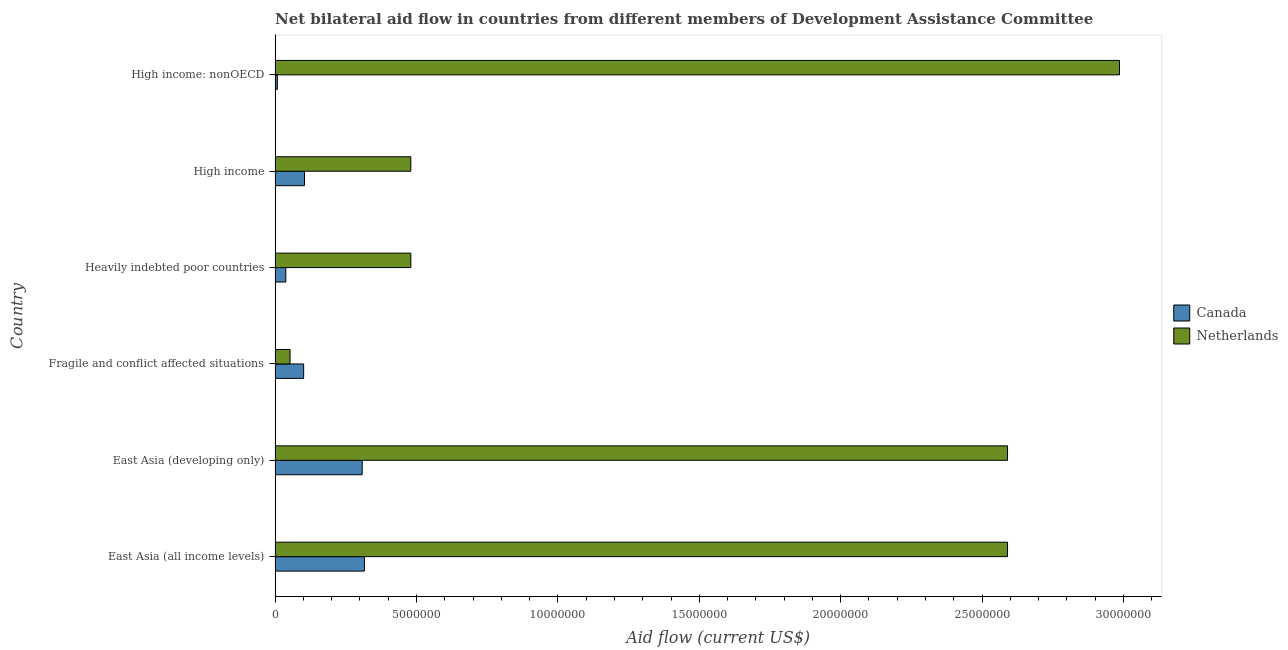How many bars are there on the 4th tick from the bottom?
Your answer should be very brief. 2. What is the label of the 1st group of bars from the top?
Provide a short and direct response. High income: nonOECD. In how many cases, is the number of bars for a given country not equal to the number of legend labels?
Your answer should be compact. 0. What is the amount of aid given by netherlands in East Asia (all income levels)?
Offer a very short reply. 2.59e+07. Across all countries, what is the maximum amount of aid given by canada?
Offer a very short reply. 3.16e+06. Across all countries, what is the minimum amount of aid given by netherlands?
Provide a short and direct response. 5.30e+05. In which country was the amount of aid given by netherlands maximum?
Give a very brief answer. High income: nonOECD. In which country was the amount of aid given by netherlands minimum?
Provide a short and direct response. Fragile and conflict affected situations. What is the total amount of aid given by canada in the graph?
Your response must be concise. 8.75e+06. What is the difference between the amount of aid given by netherlands in East Asia (all income levels) and that in Heavily indebted poor countries?
Your answer should be compact. 2.11e+07. What is the difference between the amount of aid given by canada in East Asia (all income levels) and the amount of aid given by netherlands in High income: nonOECD?
Your response must be concise. -2.67e+07. What is the average amount of aid given by canada per country?
Offer a very short reply. 1.46e+06. What is the difference between the amount of aid given by netherlands and amount of aid given by canada in East Asia (all income levels)?
Provide a short and direct response. 2.27e+07. In how many countries, is the amount of aid given by netherlands greater than 21000000 US$?
Provide a short and direct response. 3. What is the ratio of the amount of aid given by canada in Fragile and conflict affected situations to that in Heavily indebted poor countries?
Ensure brevity in your answer.  2.66. Is the amount of aid given by canada in East Asia (developing only) less than that in Fragile and conflict affected situations?
Make the answer very short. No. What is the difference between the highest and the second highest amount of aid given by netherlands?
Keep it short and to the point. 3.96e+06. What is the difference between the highest and the lowest amount of aid given by netherlands?
Give a very brief answer. 2.93e+07. In how many countries, is the amount of aid given by netherlands greater than the average amount of aid given by netherlands taken over all countries?
Your answer should be compact. 3. What does the 1st bar from the top in High income represents?
Make the answer very short. Netherlands. How many bars are there?
Provide a succinct answer. 12. Are all the bars in the graph horizontal?
Ensure brevity in your answer.  Yes. What is the difference between two consecutive major ticks on the X-axis?
Provide a short and direct response. 5.00e+06. Does the graph contain any zero values?
Ensure brevity in your answer.  No. Does the graph contain grids?
Give a very brief answer. No. What is the title of the graph?
Offer a very short reply. Net bilateral aid flow in countries from different members of Development Assistance Committee. What is the label or title of the X-axis?
Your answer should be compact. Aid flow (current US$). What is the label or title of the Y-axis?
Offer a very short reply. Country. What is the Aid flow (current US$) of Canada in East Asia (all income levels)?
Your answer should be compact. 3.16e+06. What is the Aid flow (current US$) in Netherlands in East Asia (all income levels)?
Give a very brief answer. 2.59e+07. What is the Aid flow (current US$) of Canada in East Asia (developing only)?
Keep it short and to the point. 3.08e+06. What is the Aid flow (current US$) in Netherlands in East Asia (developing only)?
Provide a succinct answer. 2.59e+07. What is the Aid flow (current US$) of Canada in Fragile and conflict affected situations?
Offer a very short reply. 1.01e+06. What is the Aid flow (current US$) in Netherlands in Fragile and conflict affected situations?
Give a very brief answer. 5.30e+05. What is the Aid flow (current US$) of Canada in Heavily indebted poor countries?
Your response must be concise. 3.80e+05. What is the Aid flow (current US$) in Netherlands in Heavily indebted poor countries?
Your answer should be very brief. 4.80e+06. What is the Aid flow (current US$) in Canada in High income?
Offer a terse response. 1.04e+06. What is the Aid flow (current US$) in Netherlands in High income?
Offer a terse response. 4.80e+06. What is the Aid flow (current US$) of Netherlands in High income: nonOECD?
Ensure brevity in your answer.  2.99e+07. Across all countries, what is the maximum Aid flow (current US$) in Canada?
Provide a short and direct response. 3.16e+06. Across all countries, what is the maximum Aid flow (current US$) in Netherlands?
Your response must be concise. 2.99e+07. Across all countries, what is the minimum Aid flow (current US$) in Netherlands?
Provide a succinct answer. 5.30e+05. What is the total Aid flow (current US$) of Canada in the graph?
Offer a very short reply. 8.75e+06. What is the total Aid flow (current US$) in Netherlands in the graph?
Keep it short and to the point. 9.18e+07. What is the difference between the Aid flow (current US$) of Canada in East Asia (all income levels) and that in East Asia (developing only)?
Your answer should be very brief. 8.00e+04. What is the difference between the Aid flow (current US$) in Netherlands in East Asia (all income levels) and that in East Asia (developing only)?
Make the answer very short. 0. What is the difference between the Aid flow (current US$) of Canada in East Asia (all income levels) and that in Fragile and conflict affected situations?
Give a very brief answer. 2.15e+06. What is the difference between the Aid flow (current US$) of Netherlands in East Asia (all income levels) and that in Fragile and conflict affected situations?
Provide a short and direct response. 2.54e+07. What is the difference between the Aid flow (current US$) in Canada in East Asia (all income levels) and that in Heavily indebted poor countries?
Provide a succinct answer. 2.78e+06. What is the difference between the Aid flow (current US$) in Netherlands in East Asia (all income levels) and that in Heavily indebted poor countries?
Offer a terse response. 2.11e+07. What is the difference between the Aid flow (current US$) of Canada in East Asia (all income levels) and that in High income?
Offer a very short reply. 2.12e+06. What is the difference between the Aid flow (current US$) of Netherlands in East Asia (all income levels) and that in High income?
Your answer should be very brief. 2.11e+07. What is the difference between the Aid flow (current US$) in Canada in East Asia (all income levels) and that in High income: nonOECD?
Your answer should be compact. 3.08e+06. What is the difference between the Aid flow (current US$) of Netherlands in East Asia (all income levels) and that in High income: nonOECD?
Provide a short and direct response. -3.96e+06. What is the difference between the Aid flow (current US$) in Canada in East Asia (developing only) and that in Fragile and conflict affected situations?
Offer a terse response. 2.07e+06. What is the difference between the Aid flow (current US$) in Netherlands in East Asia (developing only) and that in Fragile and conflict affected situations?
Your answer should be compact. 2.54e+07. What is the difference between the Aid flow (current US$) in Canada in East Asia (developing only) and that in Heavily indebted poor countries?
Give a very brief answer. 2.70e+06. What is the difference between the Aid flow (current US$) of Netherlands in East Asia (developing only) and that in Heavily indebted poor countries?
Offer a terse response. 2.11e+07. What is the difference between the Aid flow (current US$) of Canada in East Asia (developing only) and that in High income?
Ensure brevity in your answer.  2.04e+06. What is the difference between the Aid flow (current US$) of Netherlands in East Asia (developing only) and that in High income?
Offer a terse response. 2.11e+07. What is the difference between the Aid flow (current US$) of Canada in East Asia (developing only) and that in High income: nonOECD?
Your answer should be very brief. 3.00e+06. What is the difference between the Aid flow (current US$) in Netherlands in East Asia (developing only) and that in High income: nonOECD?
Your answer should be very brief. -3.96e+06. What is the difference between the Aid flow (current US$) of Canada in Fragile and conflict affected situations and that in Heavily indebted poor countries?
Ensure brevity in your answer.  6.30e+05. What is the difference between the Aid flow (current US$) in Netherlands in Fragile and conflict affected situations and that in Heavily indebted poor countries?
Ensure brevity in your answer.  -4.27e+06. What is the difference between the Aid flow (current US$) of Canada in Fragile and conflict affected situations and that in High income?
Make the answer very short. -3.00e+04. What is the difference between the Aid flow (current US$) of Netherlands in Fragile and conflict affected situations and that in High income?
Your response must be concise. -4.27e+06. What is the difference between the Aid flow (current US$) of Canada in Fragile and conflict affected situations and that in High income: nonOECD?
Your answer should be compact. 9.30e+05. What is the difference between the Aid flow (current US$) in Netherlands in Fragile and conflict affected situations and that in High income: nonOECD?
Give a very brief answer. -2.93e+07. What is the difference between the Aid flow (current US$) of Canada in Heavily indebted poor countries and that in High income?
Provide a succinct answer. -6.60e+05. What is the difference between the Aid flow (current US$) of Netherlands in Heavily indebted poor countries and that in High income?
Provide a succinct answer. 0. What is the difference between the Aid flow (current US$) in Canada in Heavily indebted poor countries and that in High income: nonOECD?
Offer a terse response. 3.00e+05. What is the difference between the Aid flow (current US$) in Netherlands in Heavily indebted poor countries and that in High income: nonOECD?
Your response must be concise. -2.51e+07. What is the difference between the Aid flow (current US$) of Canada in High income and that in High income: nonOECD?
Your answer should be compact. 9.60e+05. What is the difference between the Aid flow (current US$) in Netherlands in High income and that in High income: nonOECD?
Give a very brief answer. -2.51e+07. What is the difference between the Aid flow (current US$) of Canada in East Asia (all income levels) and the Aid flow (current US$) of Netherlands in East Asia (developing only)?
Provide a succinct answer. -2.27e+07. What is the difference between the Aid flow (current US$) in Canada in East Asia (all income levels) and the Aid flow (current US$) in Netherlands in Fragile and conflict affected situations?
Provide a succinct answer. 2.63e+06. What is the difference between the Aid flow (current US$) in Canada in East Asia (all income levels) and the Aid flow (current US$) in Netherlands in Heavily indebted poor countries?
Ensure brevity in your answer.  -1.64e+06. What is the difference between the Aid flow (current US$) of Canada in East Asia (all income levels) and the Aid flow (current US$) of Netherlands in High income?
Provide a short and direct response. -1.64e+06. What is the difference between the Aid flow (current US$) in Canada in East Asia (all income levels) and the Aid flow (current US$) in Netherlands in High income: nonOECD?
Provide a short and direct response. -2.67e+07. What is the difference between the Aid flow (current US$) of Canada in East Asia (developing only) and the Aid flow (current US$) of Netherlands in Fragile and conflict affected situations?
Your answer should be compact. 2.55e+06. What is the difference between the Aid flow (current US$) of Canada in East Asia (developing only) and the Aid flow (current US$) of Netherlands in Heavily indebted poor countries?
Your answer should be compact. -1.72e+06. What is the difference between the Aid flow (current US$) in Canada in East Asia (developing only) and the Aid flow (current US$) in Netherlands in High income?
Make the answer very short. -1.72e+06. What is the difference between the Aid flow (current US$) of Canada in East Asia (developing only) and the Aid flow (current US$) of Netherlands in High income: nonOECD?
Ensure brevity in your answer.  -2.68e+07. What is the difference between the Aid flow (current US$) in Canada in Fragile and conflict affected situations and the Aid flow (current US$) in Netherlands in Heavily indebted poor countries?
Offer a terse response. -3.79e+06. What is the difference between the Aid flow (current US$) of Canada in Fragile and conflict affected situations and the Aid flow (current US$) of Netherlands in High income?
Offer a very short reply. -3.79e+06. What is the difference between the Aid flow (current US$) in Canada in Fragile and conflict affected situations and the Aid flow (current US$) in Netherlands in High income: nonOECD?
Your answer should be compact. -2.88e+07. What is the difference between the Aid flow (current US$) of Canada in Heavily indebted poor countries and the Aid flow (current US$) of Netherlands in High income?
Your response must be concise. -4.42e+06. What is the difference between the Aid flow (current US$) of Canada in Heavily indebted poor countries and the Aid flow (current US$) of Netherlands in High income: nonOECD?
Offer a terse response. -2.95e+07. What is the difference between the Aid flow (current US$) in Canada in High income and the Aid flow (current US$) in Netherlands in High income: nonOECD?
Give a very brief answer. -2.88e+07. What is the average Aid flow (current US$) of Canada per country?
Offer a terse response. 1.46e+06. What is the average Aid flow (current US$) in Netherlands per country?
Your answer should be compact. 1.53e+07. What is the difference between the Aid flow (current US$) of Canada and Aid flow (current US$) of Netherlands in East Asia (all income levels)?
Ensure brevity in your answer.  -2.27e+07. What is the difference between the Aid flow (current US$) of Canada and Aid flow (current US$) of Netherlands in East Asia (developing only)?
Give a very brief answer. -2.28e+07. What is the difference between the Aid flow (current US$) of Canada and Aid flow (current US$) of Netherlands in Heavily indebted poor countries?
Your answer should be compact. -4.42e+06. What is the difference between the Aid flow (current US$) in Canada and Aid flow (current US$) in Netherlands in High income?
Your answer should be compact. -3.76e+06. What is the difference between the Aid flow (current US$) of Canada and Aid flow (current US$) of Netherlands in High income: nonOECD?
Your answer should be compact. -2.98e+07. What is the ratio of the Aid flow (current US$) in Canada in East Asia (all income levels) to that in East Asia (developing only)?
Provide a short and direct response. 1.03. What is the ratio of the Aid flow (current US$) in Netherlands in East Asia (all income levels) to that in East Asia (developing only)?
Give a very brief answer. 1. What is the ratio of the Aid flow (current US$) in Canada in East Asia (all income levels) to that in Fragile and conflict affected situations?
Your answer should be very brief. 3.13. What is the ratio of the Aid flow (current US$) of Netherlands in East Asia (all income levels) to that in Fragile and conflict affected situations?
Ensure brevity in your answer.  48.87. What is the ratio of the Aid flow (current US$) of Canada in East Asia (all income levels) to that in Heavily indebted poor countries?
Keep it short and to the point. 8.32. What is the ratio of the Aid flow (current US$) of Netherlands in East Asia (all income levels) to that in Heavily indebted poor countries?
Make the answer very short. 5.4. What is the ratio of the Aid flow (current US$) in Canada in East Asia (all income levels) to that in High income?
Keep it short and to the point. 3.04. What is the ratio of the Aid flow (current US$) of Netherlands in East Asia (all income levels) to that in High income?
Ensure brevity in your answer.  5.4. What is the ratio of the Aid flow (current US$) of Canada in East Asia (all income levels) to that in High income: nonOECD?
Your answer should be very brief. 39.5. What is the ratio of the Aid flow (current US$) in Netherlands in East Asia (all income levels) to that in High income: nonOECD?
Give a very brief answer. 0.87. What is the ratio of the Aid flow (current US$) in Canada in East Asia (developing only) to that in Fragile and conflict affected situations?
Give a very brief answer. 3.05. What is the ratio of the Aid flow (current US$) of Netherlands in East Asia (developing only) to that in Fragile and conflict affected situations?
Ensure brevity in your answer.  48.87. What is the ratio of the Aid flow (current US$) of Canada in East Asia (developing only) to that in Heavily indebted poor countries?
Your response must be concise. 8.11. What is the ratio of the Aid flow (current US$) of Netherlands in East Asia (developing only) to that in Heavily indebted poor countries?
Your response must be concise. 5.4. What is the ratio of the Aid flow (current US$) of Canada in East Asia (developing only) to that in High income?
Your response must be concise. 2.96. What is the ratio of the Aid flow (current US$) in Netherlands in East Asia (developing only) to that in High income?
Provide a short and direct response. 5.4. What is the ratio of the Aid flow (current US$) in Canada in East Asia (developing only) to that in High income: nonOECD?
Make the answer very short. 38.5. What is the ratio of the Aid flow (current US$) in Netherlands in East Asia (developing only) to that in High income: nonOECD?
Give a very brief answer. 0.87. What is the ratio of the Aid flow (current US$) of Canada in Fragile and conflict affected situations to that in Heavily indebted poor countries?
Your answer should be very brief. 2.66. What is the ratio of the Aid flow (current US$) of Netherlands in Fragile and conflict affected situations to that in Heavily indebted poor countries?
Offer a very short reply. 0.11. What is the ratio of the Aid flow (current US$) in Canada in Fragile and conflict affected situations to that in High income?
Offer a very short reply. 0.97. What is the ratio of the Aid flow (current US$) of Netherlands in Fragile and conflict affected situations to that in High income?
Ensure brevity in your answer.  0.11. What is the ratio of the Aid flow (current US$) in Canada in Fragile and conflict affected situations to that in High income: nonOECD?
Keep it short and to the point. 12.62. What is the ratio of the Aid flow (current US$) in Netherlands in Fragile and conflict affected situations to that in High income: nonOECD?
Keep it short and to the point. 0.02. What is the ratio of the Aid flow (current US$) in Canada in Heavily indebted poor countries to that in High income?
Your response must be concise. 0.37. What is the ratio of the Aid flow (current US$) of Netherlands in Heavily indebted poor countries to that in High income?
Your answer should be very brief. 1. What is the ratio of the Aid flow (current US$) of Canada in Heavily indebted poor countries to that in High income: nonOECD?
Your response must be concise. 4.75. What is the ratio of the Aid flow (current US$) of Netherlands in Heavily indebted poor countries to that in High income: nonOECD?
Ensure brevity in your answer.  0.16. What is the ratio of the Aid flow (current US$) in Canada in High income to that in High income: nonOECD?
Ensure brevity in your answer.  13. What is the ratio of the Aid flow (current US$) of Netherlands in High income to that in High income: nonOECD?
Make the answer very short. 0.16. What is the difference between the highest and the second highest Aid flow (current US$) in Canada?
Keep it short and to the point. 8.00e+04. What is the difference between the highest and the second highest Aid flow (current US$) in Netherlands?
Keep it short and to the point. 3.96e+06. What is the difference between the highest and the lowest Aid flow (current US$) of Canada?
Offer a terse response. 3.08e+06. What is the difference between the highest and the lowest Aid flow (current US$) of Netherlands?
Provide a short and direct response. 2.93e+07. 